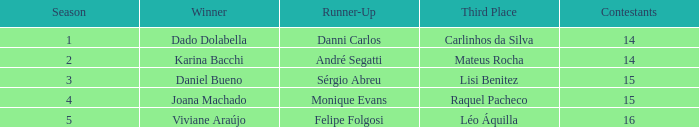In what season did Raquel Pacheco finish in third place? 4.0. 